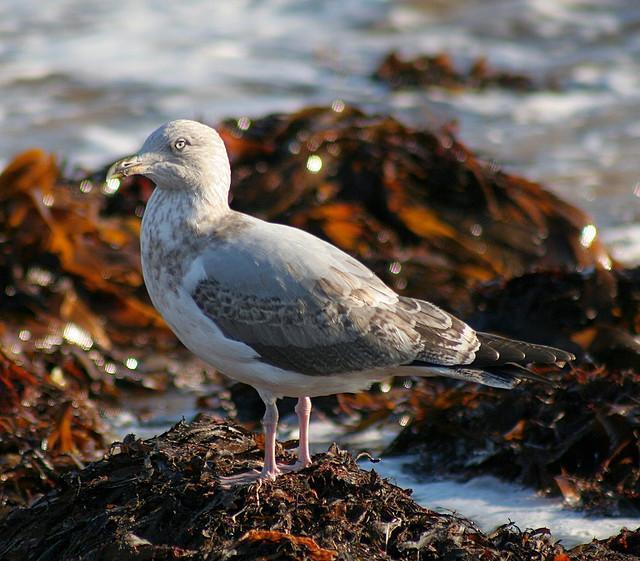How many people are in the picture?
Give a very brief answer. 0. 